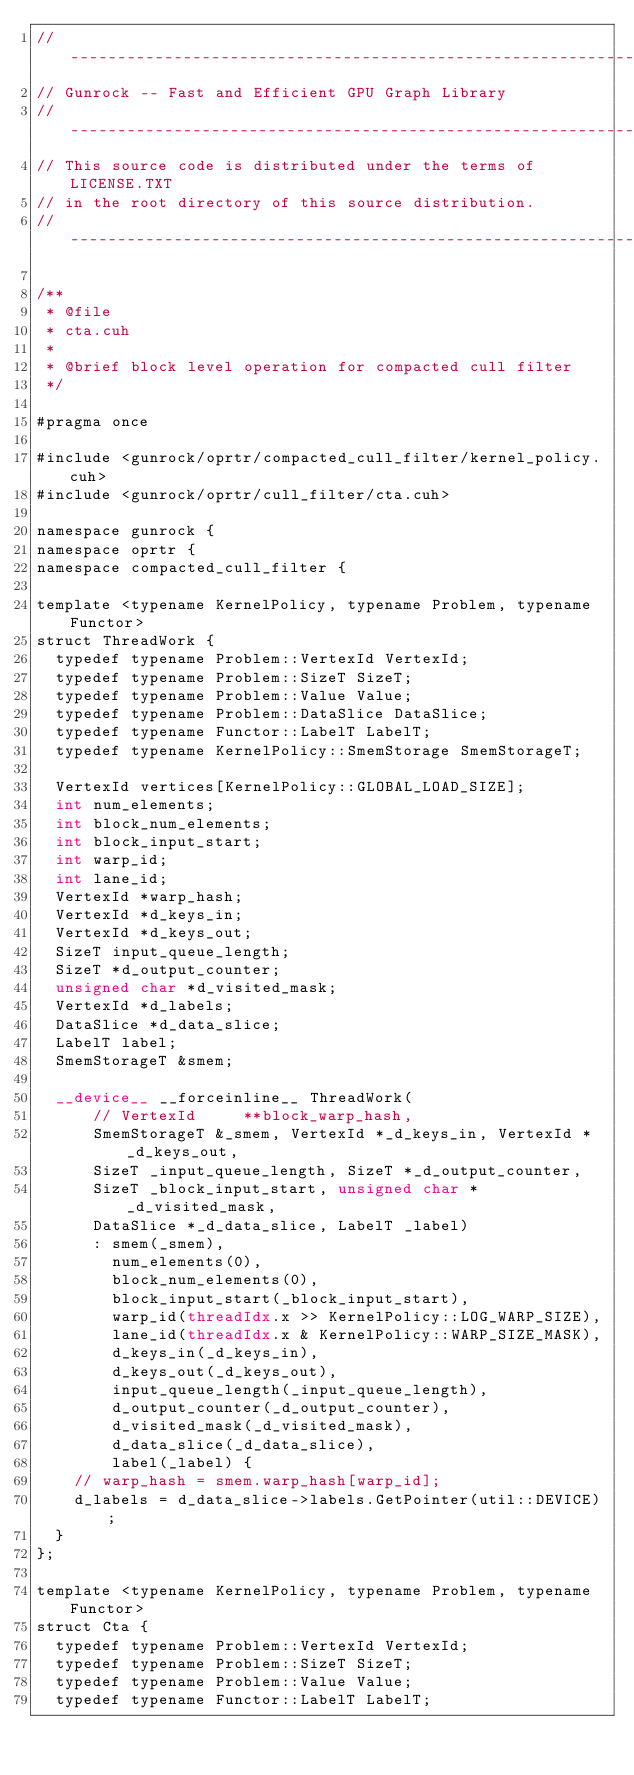Convert code to text. <code><loc_0><loc_0><loc_500><loc_500><_Cuda_>// ----------------------------------------------------------------
// Gunrock -- Fast and Efficient GPU Graph Library
// ----------------------------------------------------------------
// This source code is distributed under the terms of LICENSE.TXT
// in the root directory of this source distribution.
// ----------------------------------------------------------------

/**
 * @file
 * cta.cuh
 *
 * @brief block level operation for compacted cull filter
 */

#pragma once

#include <gunrock/oprtr/compacted_cull_filter/kernel_policy.cuh>
#include <gunrock/oprtr/cull_filter/cta.cuh>

namespace gunrock {
namespace oprtr {
namespace compacted_cull_filter {

template <typename KernelPolicy, typename Problem, typename Functor>
struct ThreadWork {
  typedef typename Problem::VertexId VertexId;
  typedef typename Problem::SizeT SizeT;
  typedef typename Problem::Value Value;
  typedef typename Problem::DataSlice DataSlice;
  typedef typename Functor::LabelT LabelT;
  typedef typename KernelPolicy::SmemStorage SmemStorageT;

  VertexId vertices[KernelPolicy::GLOBAL_LOAD_SIZE];
  int num_elements;
  int block_num_elements;
  int block_input_start;
  int warp_id;
  int lane_id;
  VertexId *warp_hash;
  VertexId *d_keys_in;
  VertexId *d_keys_out;
  SizeT input_queue_length;
  SizeT *d_output_counter;
  unsigned char *d_visited_mask;
  VertexId *d_labels;
  DataSlice *d_data_slice;
  LabelT label;
  SmemStorageT &smem;

  __device__ __forceinline__ ThreadWork(
      // VertexId     **block_warp_hash,
      SmemStorageT &_smem, VertexId *_d_keys_in, VertexId *_d_keys_out,
      SizeT _input_queue_length, SizeT *_d_output_counter,
      SizeT _block_input_start, unsigned char *_d_visited_mask,
      DataSlice *_d_data_slice, LabelT _label)
      : smem(_smem),
        num_elements(0),
        block_num_elements(0),
        block_input_start(_block_input_start),
        warp_id(threadIdx.x >> KernelPolicy::LOG_WARP_SIZE),
        lane_id(threadIdx.x & KernelPolicy::WARP_SIZE_MASK),
        d_keys_in(_d_keys_in),
        d_keys_out(_d_keys_out),
        input_queue_length(_input_queue_length),
        d_output_counter(_d_output_counter),
        d_visited_mask(_d_visited_mask),
        d_data_slice(_d_data_slice),
        label(_label) {
    // warp_hash = smem.warp_hash[warp_id];
    d_labels = d_data_slice->labels.GetPointer(util::DEVICE);
  }
};

template <typename KernelPolicy, typename Problem, typename Functor>
struct Cta {
  typedef typename Problem::VertexId VertexId;
  typedef typename Problem::SizeT SizeT;
  typedef typename Problem::Value Value;
  typedef typename Functor::LabelT LabelT;</code> 